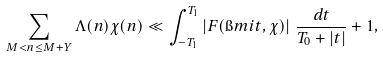Convert formula to latex. <formula><loc_0><loc_0><loc_500><loc_500>\sum _ { M < n \leq M + Y } \Lambda ( n ) \chi ( n ) \ll \int _ { - T _ { 1 } } ^ { T _ { 1 } } \left | F ( \i m i t , \chi ) \right | \, \frac { d t } { T _ { 0 } + | t | } + 1 ,</formula> 